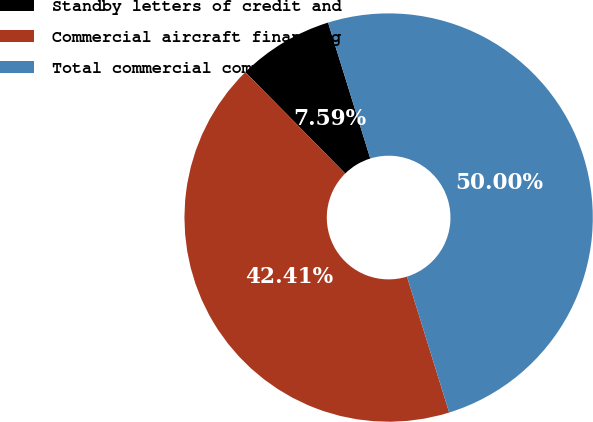Convert chart. <chart><loc_0><loc_0><loc_500><loc_500><pie_chart><fcel>Standby letters of credit and<fcel>Commercial aircraft financing<fcel>Total commercial commitments<nl><fcel>7.59%<fcel>42.41%<fcel>50.0%<nl></chart> 